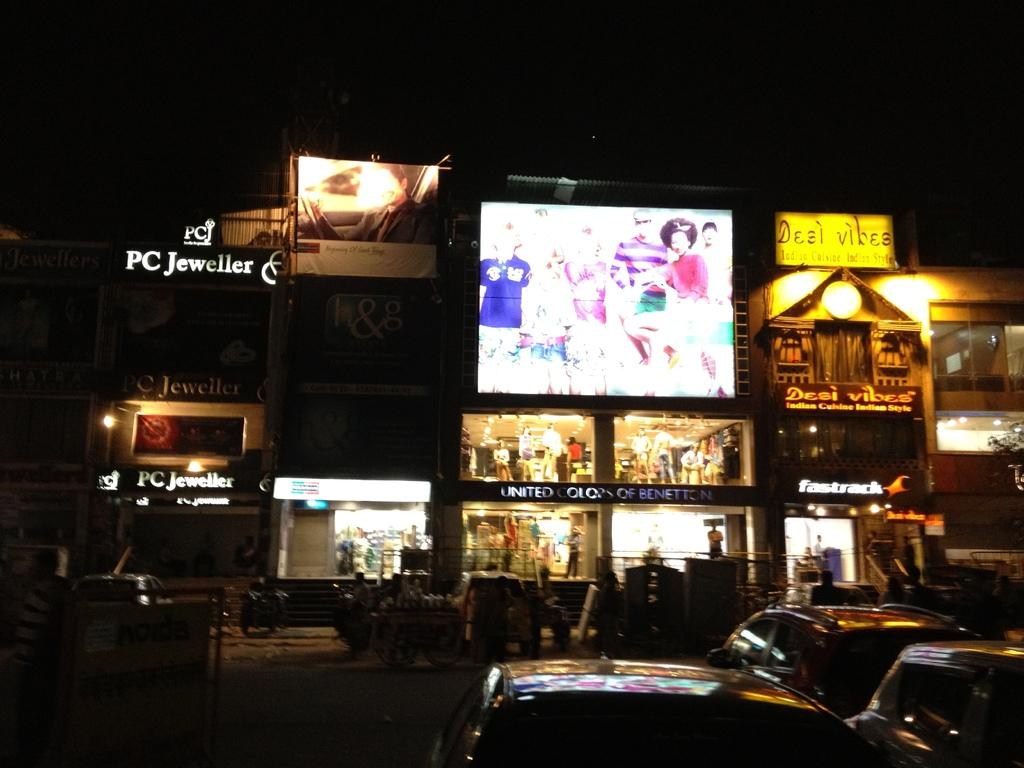<image>
Summarize the visual content of the image. the front of a bar that is named desi vibes on a yellow sign. 